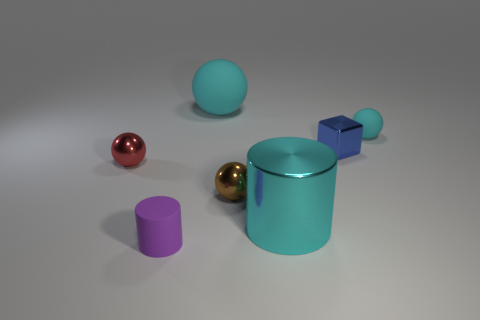Subtract all brown cubes. How many cyan spheres are left? 2 Subtract all tiny cyan rubber balls. How many balls are left? 3 Subtract all red balls. How many balls are left? 3 Add 2 blue metal blocks. How many objects exist? 9 Subtract all red balls. Subtract all gray cubes. How many balls are left? 3 Subtract all balls. How many objects are left? 3 Add 1 cyan rubber balls. How many cyan rubber balls are left? 3 Add 3 small rubber objects. How many small rubber objects exist? 5 Subtract 0 purple spheres. How many objects are left? 7 Subtract all cyan rubber things. Subtract all shiny balls. How many objects are left? 3 